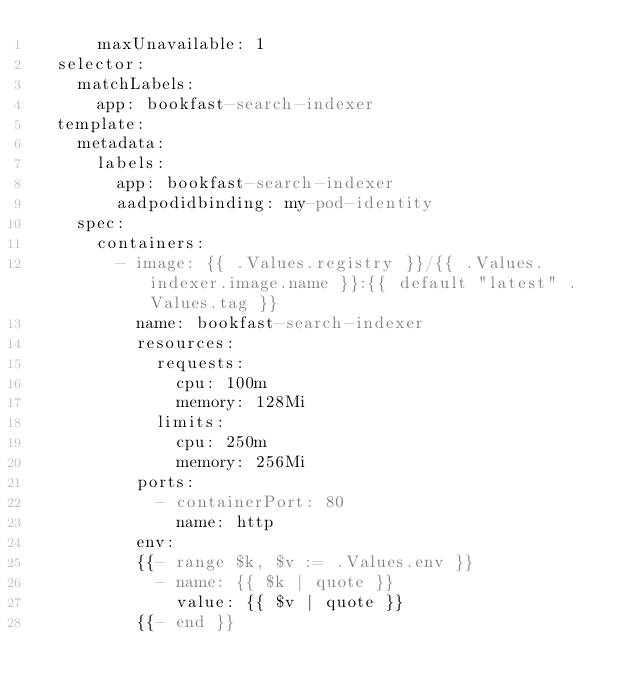<code> <loc_0><loc_0><loc_500><loc_500><_YAML_>      maxUnavailable: 1
  selector:
    matchLabels:
      app: bookfast-search-indexer
  template:
    metadata:
      labels:
        app: bookfast-search-indexer
        aadpodidbinding: my-pod-identity
    spec:
      containers:
        - image: {{ .Values.registry }}/{{ .Values.indexer.image.name }}:{{ default "latest" .Values.tag }}
          name: bookfast-search-indexer
          resources:
            requests:
              cpu: 100m
              memory: 128Mi
            limits:
              cpu: 250m
              memory: 256Mi
          ports:
            - containerPort: 80
              name: http
          env:
          {{- range $k, $v := .Values.env }}
            - name: {{ $k | quote }}
              value: {{ $v | quote }}
          {{- end }}
</code> 